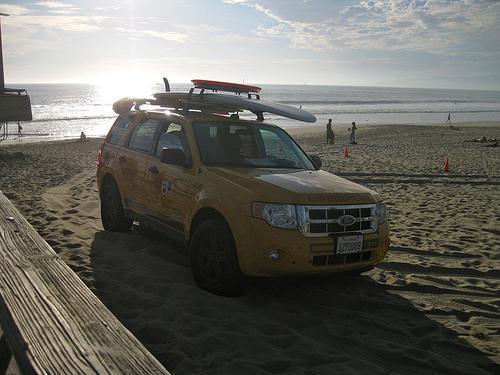How many doors does the SUV have?
Give a very brief answer. 4. How many black wheels are visible?
Give a very brief answer. 2. 